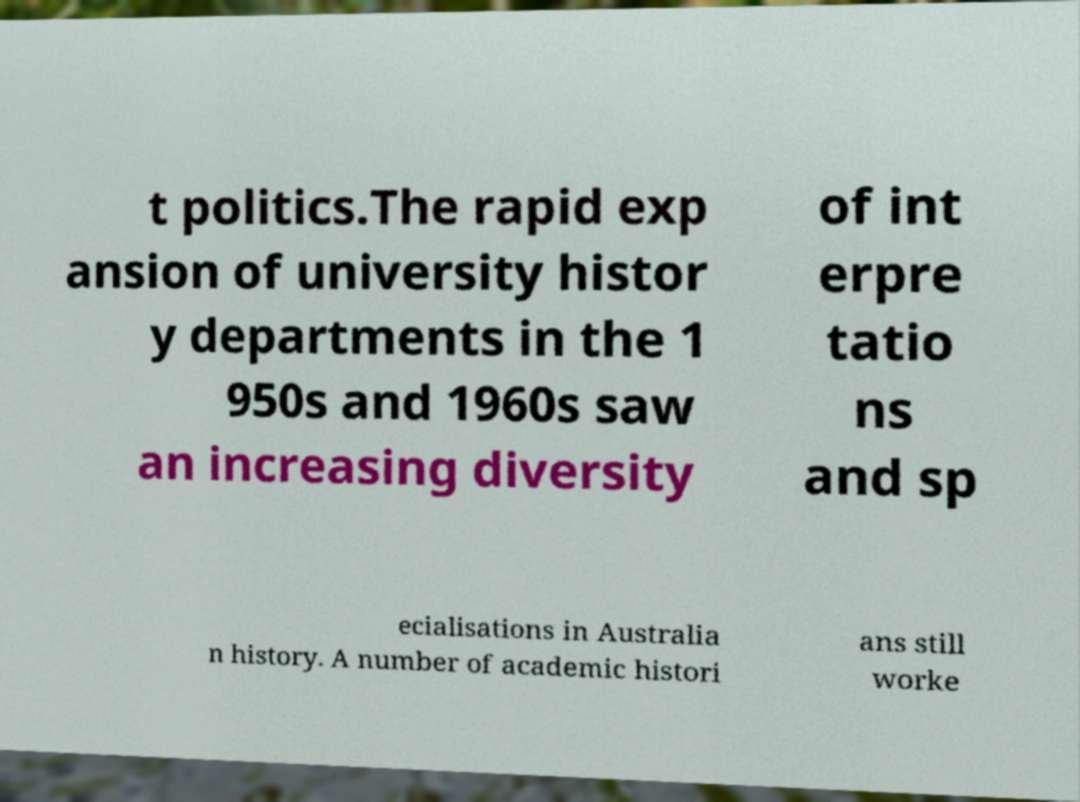There's text embedded in this image that I need extracted. Can you transcribe it verbatim? t politics.The rapid exp ansion of university histor y departments in the 1 950s and 1960s saw an increasing diversity of int erpre tatio ns and sp ecialisations in Australia n history. A number of academic histori ans still worke 